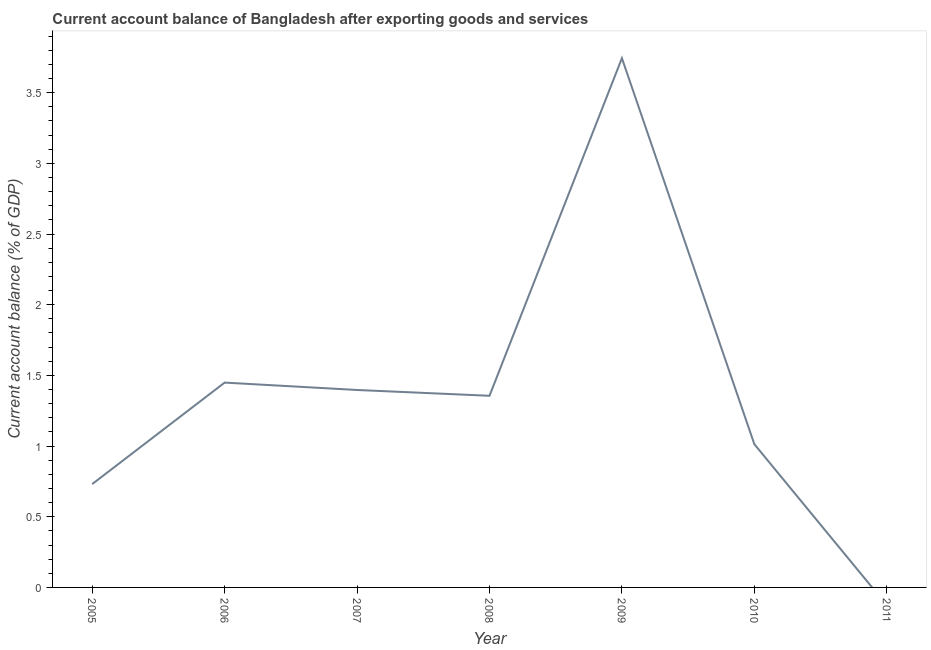What is the current account balance in 2008?
Keep it short and to the point. 1.36. Across all years, what is the maximum current account balance?
Provide a short and direct response. 3.74. Across all years, what is the minimum current account balance?
Your answer should be compact. 0. In which year was the current account balance maximum?
Offer a terse response. 2009. What is the sum of the current account balance?
Keep it short and to the point. 9.69. What is the difference between the current account balance in 2008 and 2010?
Provide a short and direct response. 0.34. What is the average current account balance per year?
Give a very brief answer. 1.38. What is the median current account balance?
Give a very brief answer. 1.36. What is the ratio of the current account balance in 2007 to that in 2008?
Provide a succinct answer. 1.03. Is the current account balance in 2005 less than that in 2006?
Your answer should be very brief. Yes. What is the difference between the highest and the second highest current account balance?
Ensure brevity in your answer.  2.3. What is the difference between the highest and the lowest current account balance?
Offer a very short reply. 3.74. In how many years, is the current account balance greater than the average current account balance taken over all years?
Offer a very short reply. 3. Does the current account balance monotonically increase over the years?
Your response must be concise. No. How many years are there in the graph?
Your response must be concise. 7. Are the values on the major ticks of Y-axis written in scientific E-notation?
Make the answer very short. No. Does the graph contain grids?
Provide a succinct answer. No. What is the title of the graph?
Give a very brief answer. Current account balance of Bangladesh after exporting goods and services. What is the label or title of the Y-axis?
Your response must be concise. Current account balance (% of GDP). What is the Current account balance (% of GDP) in 2005?
Provide a succinct answer. 0.73. What is the Current account balance (% of GDP) of 2006?
Offer a very short reply. 1.45. What is the Current account balance (% of GDP) of 2007?
Your response must be concise. 1.4. What is the Current account balance (% of GDP) in 2008?
Make the answer very short. 1.36. What is the Current account balance (% of GDP) of 2009?
Keep it short and to the point. 3.74. What is the Current account balance (% of GDP) of 2010?
Offer a terse response. 1.01. What is the difference between the Current account balance (% of GDP) in 2005 and 2006?
Your answer should be very brief. -0.72. What is the difference between the Current account balance (% of GDP) in 2005 and 2007?
Ensure brevity in your answer.  -0.67. What is the difference between the Current account balance (% of GDP) in 2005 and 2008?
Give a very brief answer. -0.62. What is the difference between the Current account balance (% of GDP) in 2005 and 2009?
Your answer should be compact. -3.01. What is the difference between the Current account balance (% of GDP) in 2005 and 2010?
Make the answer very short. -0.28. What is the difference between the Current account balance (% of GDP) in 2006 and 2007?
Your answer should be compact. 0.05. What is the difference between the Current account balance (% of GDP) in 2006 and 2008?
Make the answer very short. 0.09. What is the difference between the Current account balance (% of GDP) in 2006 and 2009?
Make the answer very short. -2.3. What is the difference between the Current account balance (% of GDP) in 2006 and 2010?
Ensure brevity in your answer.  0.44. What is the difference between the Current account balance (% of GDP) in 2007 and 2008?
Provide a short and direct response. 0.04. What is the difference between the Current account balance (% of GDP) in 2007 and 2009?
Keep it short and to the point. -2.35. What is the difference between the Current account balance (% of GDP) in 2007 and 2010?
Give a very brief answer. 0.38. What is the difference between the Current account balance (% of GDP) in 2008 and 2009?
Your answer should be very brief. -2.39. What is the difference between the Current account balance (% of GDP) in 2008 and 2010?
Your response must be concise. 0.34. What is the difference between the Current account balance (% of GDP) in 2009 and 2010?
Offer a very short reply. 2.73. What is the ratio of the Current account balance (% of GDP) in 2005 to that in 2006?
Your response must be concise. 0.51. What is the ratio of the Current account balance (% of GDP) in 2005 to that in 2007?
Your answer should be very brief. 0.52. What is the ratio of the Current account balance (% of GDP) in 2005 to that in 2008?
Ensure brevity in your answer.  0.54. What is the ratio of the Current account balance (% of GDP) in 2005 to that in 2009?
Offer a very short reply. 0.2. What is the ratio of the Current account balance (% of GDP) in 2005 to that in 2010?
Make the answer very short. 0.72. What is the ratio of the Current account balance (% of GDP) in 2006 to that in 2007?
Your answer should be very brief. 1.04. What is the ratio of the Current account balance (% of GDP) in 2006 to that in 2008?
Your answer should be very brief. 1.07. What is the ratio of the Current account balance (% of GDP) in 2006 to that in 2009?
Provide a succinct answer. 0.39. What is the ratio of the Current account balance (% of GDP) in 2006 to that in 2010?
Offer a very short reply. 1.43. What is the ratio of the Current account balance (% of GDP) in 2007 to that in 2009?
Provide a short and direct response. 0.37. What is the ratio of the Current account balance (% of GDP) in 2007 to that in 2010?
Your answer should be compact. 1.38. What is the ratio of the Current account balance (% of GDP) in 2008 to that in 2009?
Your answer should be very brief. 0.36. What is the ratio of the Current account balance (% of GDP) in 2008 to that in 2010?
Your answer should be very brief. 1.34. What is the ratio of the Current account balance (% of GDP) in 2009 to that in 2010?
Offer a terse response. 3.69. 